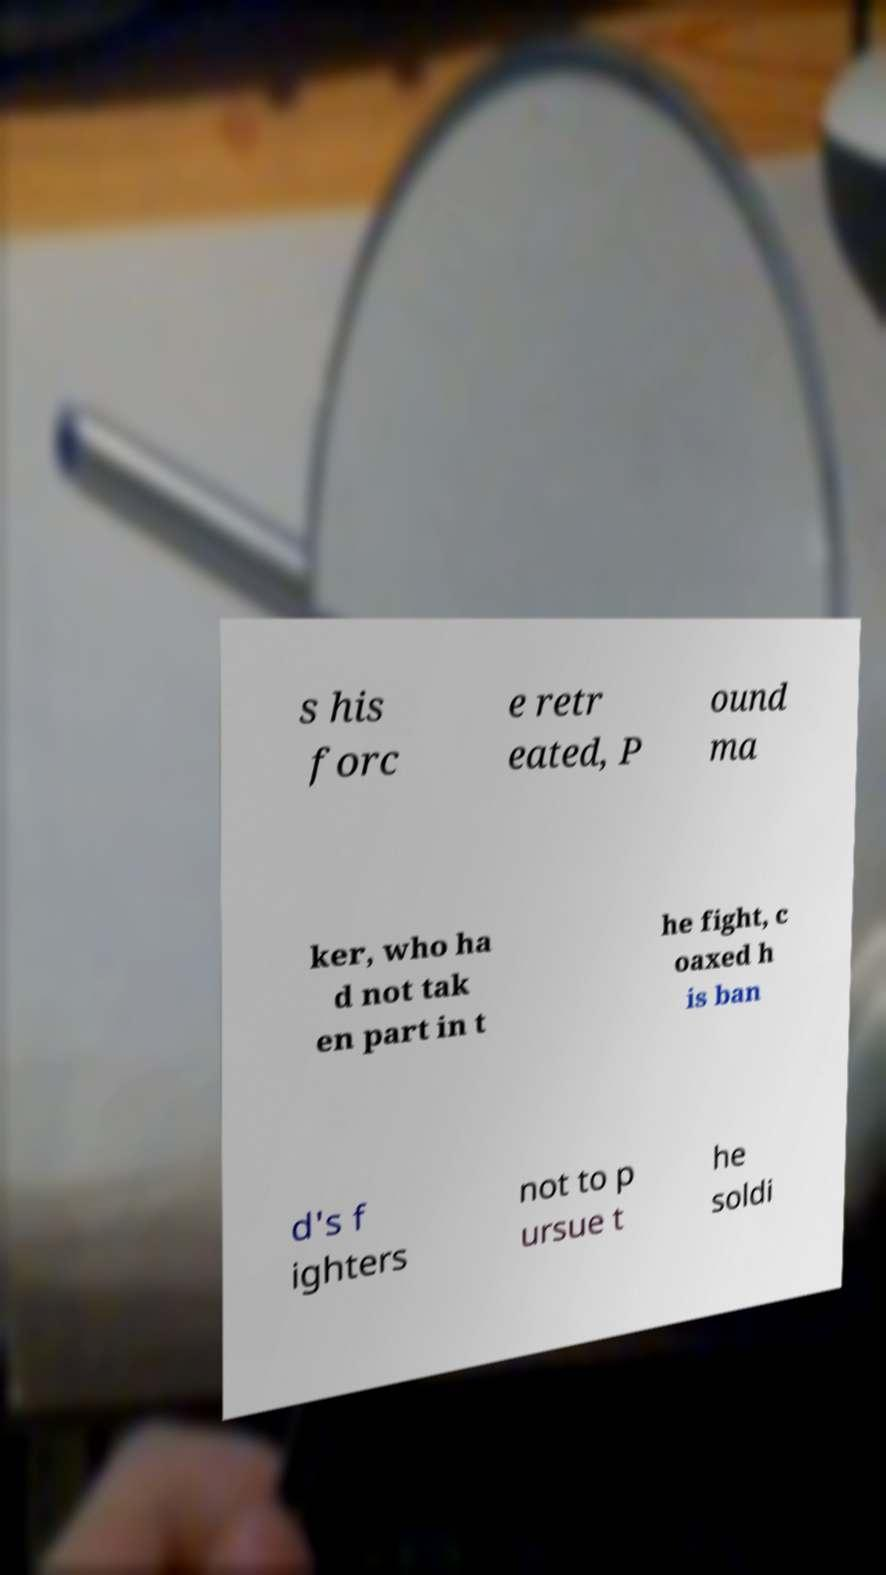Can you accurately transcribe the text from the provided image for me? s his forc e retr eated, P ound ma ker, who ha d not tak en part in t he fight, c oaxed h is ban d's f ighters not to p ursue t he soldi 